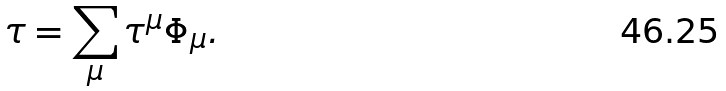<formula> <loc_0><loc_0><loc_500><loc_500>\tau = \sum _ { \mu } \tau ^ { \mu } \Phi _ { \mu } .</formula> 